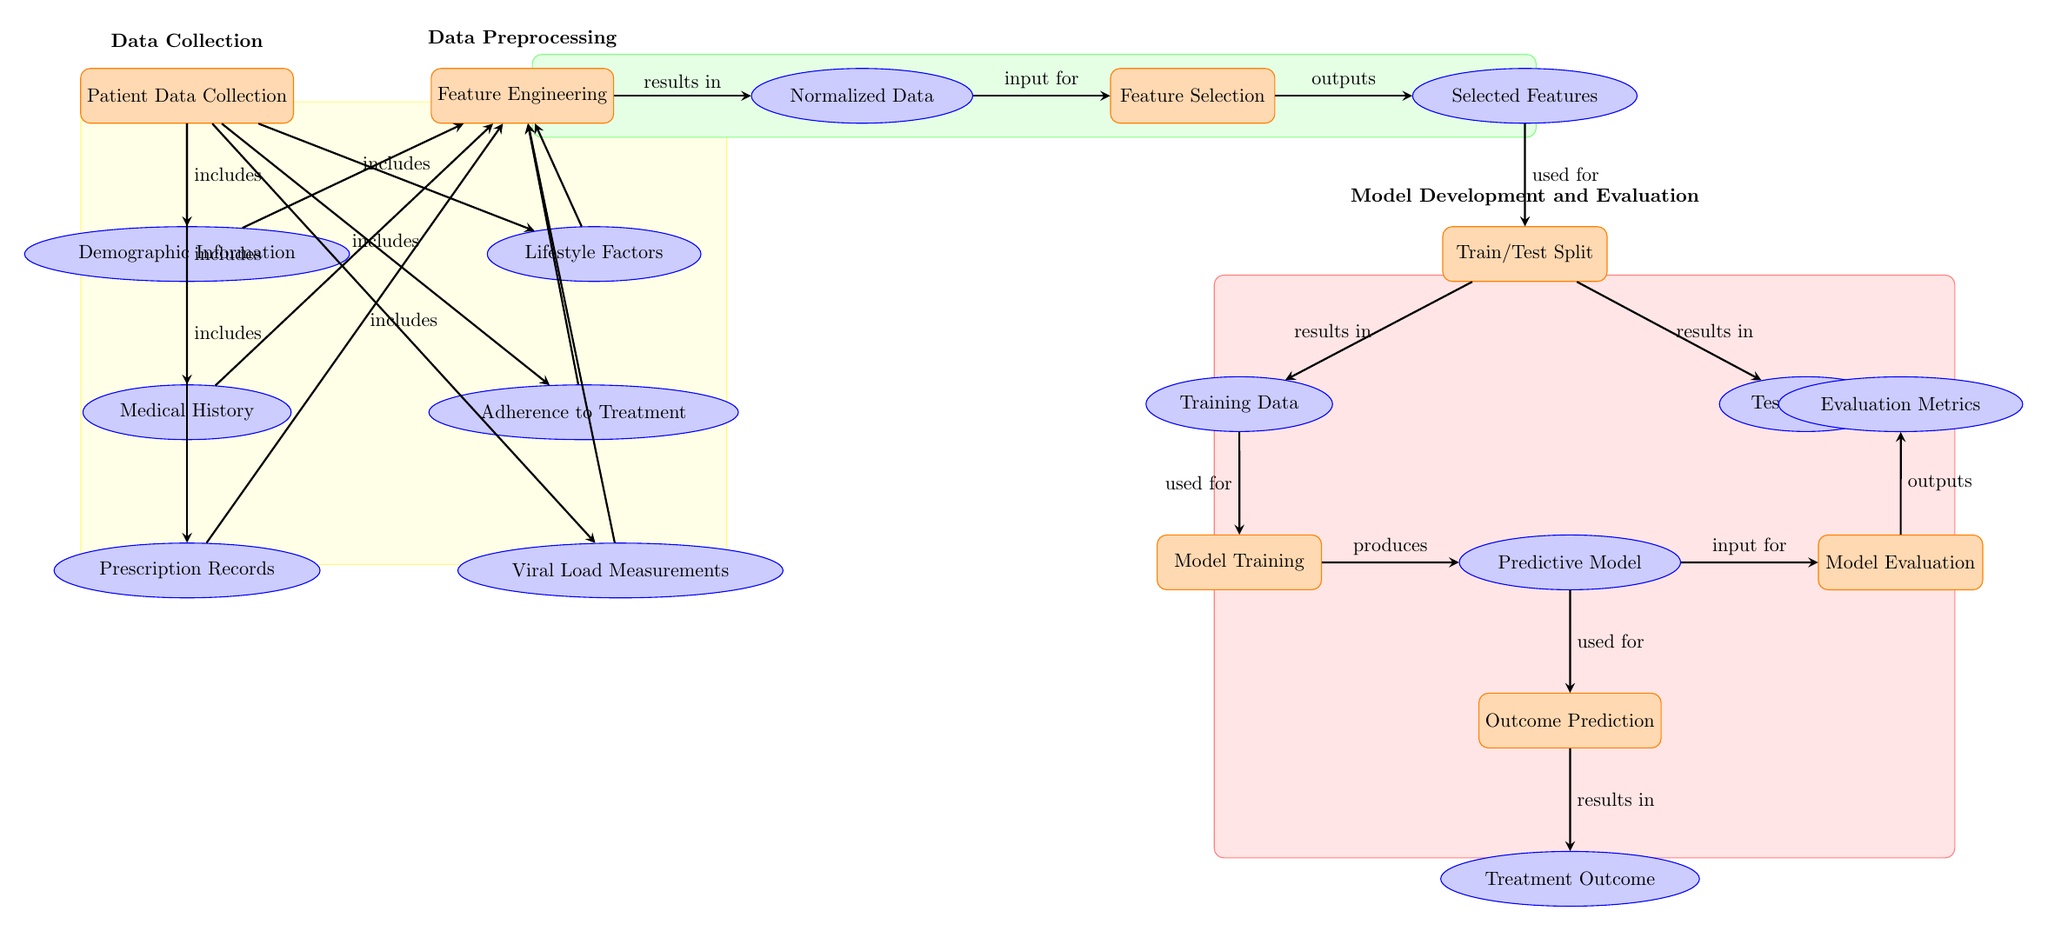What is the first process in the diagram? The first process node depicted in the diagram is "Patient Data Collection." This can be identified as the topmost process node in the structure.
Answer: Patient Data Collection How many data nodes are present in the diagram? By counting the shapes labeled as data nodes, there are a total of seven data nodes in the diagram, including demographic information, medical history, prescription records, lifestyle factors, adherence to treatment, and viral load measurements.
Answer: 7 What type of data is needed to perform the feature engineering process? The feature engineering process takes various data inputs, specifically demographic information, medical history, prescription records, lifestyle factors, adherence to treatment, and viral load measurements as indicated by the arrows leading into this node.
Answer: Normalized Data What is the outcome of the model evaluation process? The model evaluation process yields evaluation metrics, which is indicated as the output of the model evaluation node and represents the measures used to assess the predictive model's effectiveness.
Answer: Evaluation Metrics What step follows model training in the diagram? After the model training node, the next step is to evaluate the model, as indicated by the arrow leading from model training to model evaluation. This sequential relationship is shown clearly in the diagram flow.
Answer: Model Evaluation How does demographic information relate to patient data collection? Demographic information is a part of the patient data collection process, as indicated by the arrow showing that it is included in the patient data collection node. This relationship illustrates that demographic data contributes to the overall patient data collected.
Answer: Includes Which section contains the outcome prediction process? The outcome prediction process is located in the model development and evaluation section of the diagram, which is highlighted in red and contains various related processes including model training and evaluation.
Answer: Model Development and Evaluation What results from the feature selection process? The feature selection process outputs the selected features, which is clearly indicated as the next result after applying the feature selection process to the normalized data.
Answer: Selected Features 